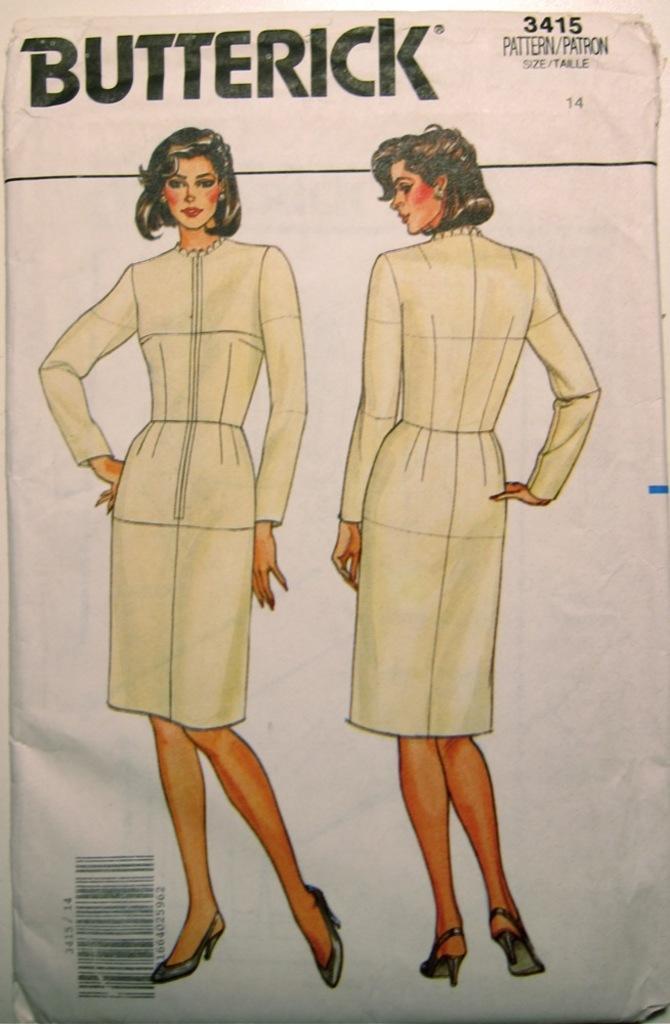Describe this image in one or two sentences. In this picture there is a poster in the image, on which there is a girl. 